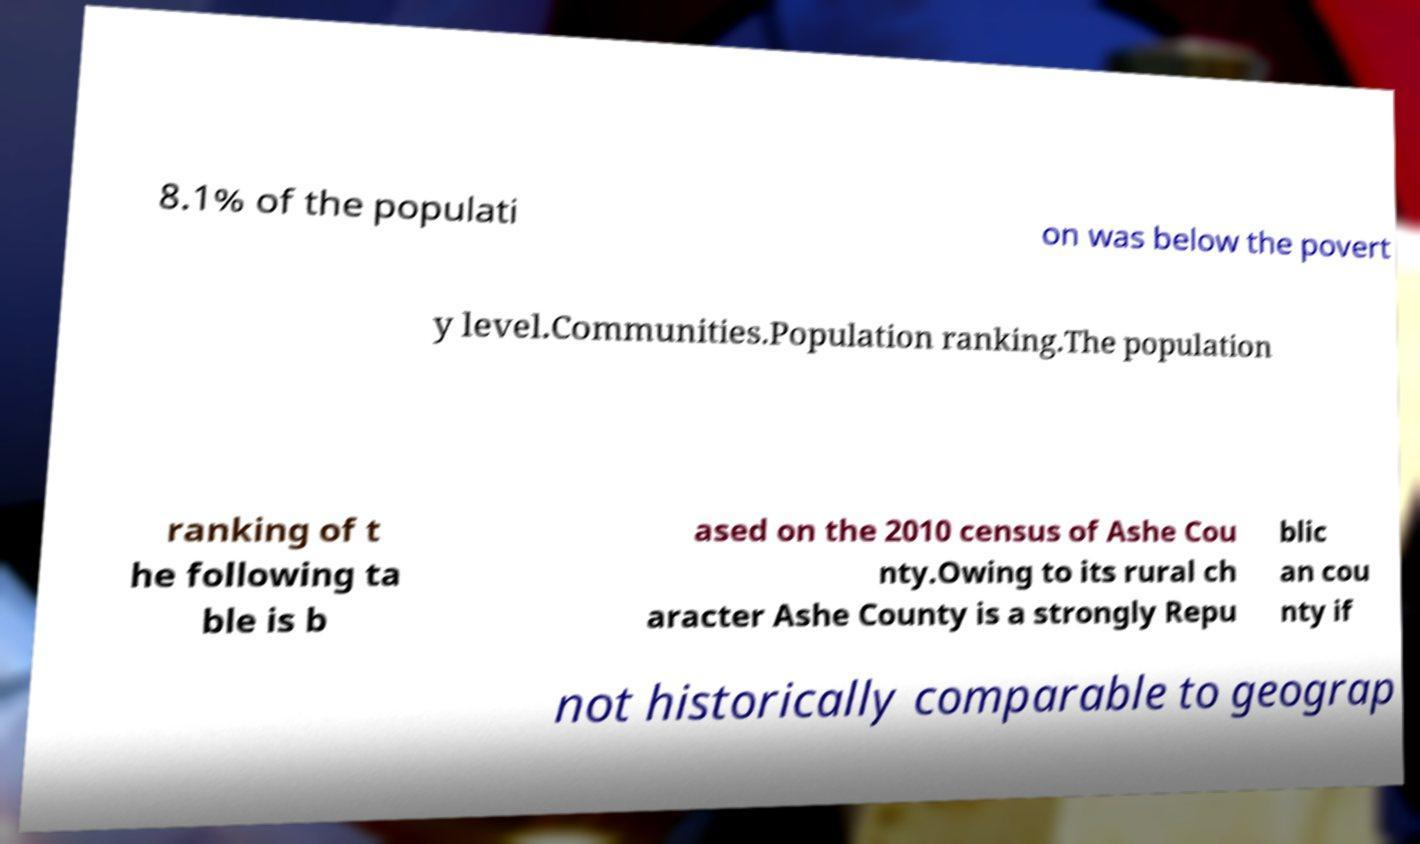What messages or text are displayed in this image? I need them in a readable, typed format. 8.1% of the populati on was below the povert y level.Communities.Population ranking.The population ranking of t he following ta ble is b ased on the 2010 census of Ashe Cou nty.Owing to its rural ch aracter Ashe County is a strongly Repu blic an cou nty if not historically comparable to geograp 